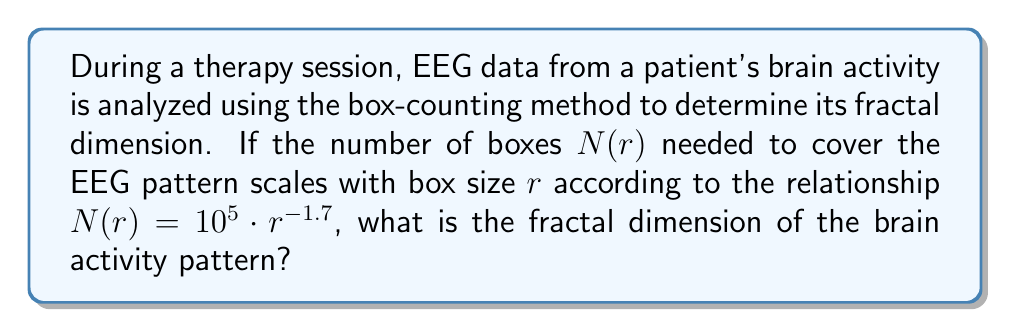Teach me how to tackle this problem. To solve this problem, we'll follow these steps:

1) The fractal dimension $D$ is defined by the box-counting method as:

   $$D = \lim_{r \to 0} \frac{\log N(r)}{\log(1/r)}$$

2) We're given that $N(r) = 10^5 \cdot r^{-1.7}$. Let's substitute this into our equation:

   $$D = \lim_{r \to 0} \frac{\log(10^5 \cdot r^{-1.7})}{\log(1/r)}$$

3) Using the properties of logarithms, we can simplify:

   $$D = \lim_{r \to 0} \frac{\log(10^5) + \log(r^{-1.7})}{\log(1/r)}$$

4) $\log(10^5)$ is a constant, and $\log(r^{-1.7}) = -1.7 \log(r)$:

   $$D = \lim_{r \to 0} \frac{\log(10^5) - 1.7\log(r)}{\log(1/r)}$$

5) $\log(1/r) = -\log(r)$, so:

   $$D = \lim_{r \to 0} \frac{\log(10^5) - 1.7\log(r)}{-\log(r)}$$

6) As $r$ approaches 0, $\log(r)$ becomes very large negative number. The constant term $\log(10^5)$ becomes negligible:

   $$D = \lim_{r \to 0} \frac{- 1.7\log(r)}{-\log(r)} = 1.7$$

Thus, the fractal dimension of the brain activity pattern is 1.7.
Answer: 1.7 